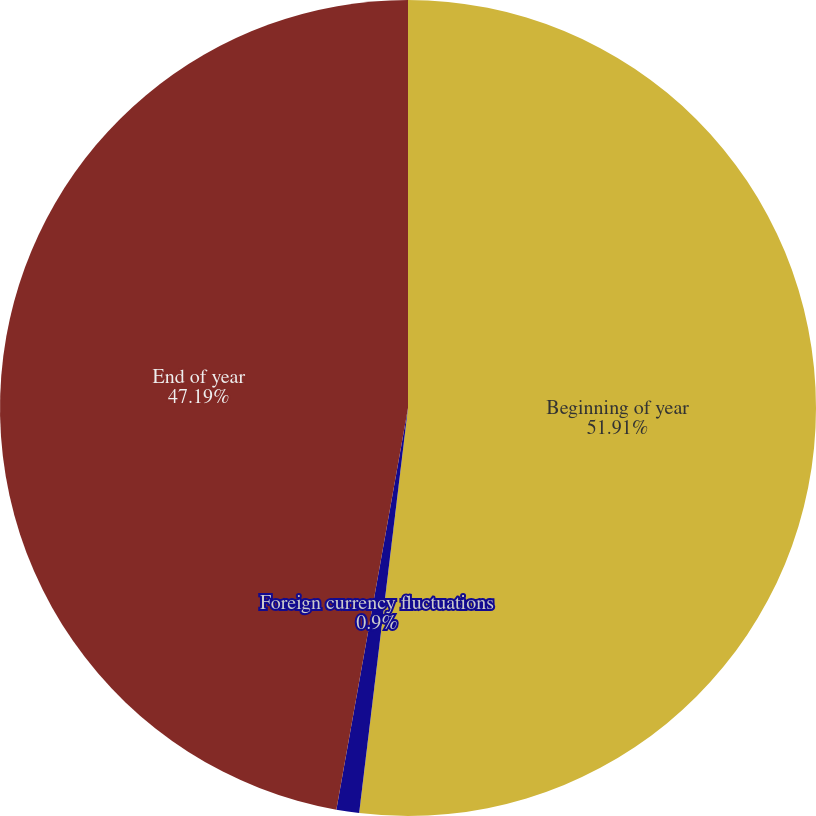Convert chart to OTSL. <chart><loc_0><loc_0><loc_500><loc_500><pie_chart><fcel>Beginning of year<fcel>Foreign currency fluctuations<fcel>End of year<nl><fcel>51.91%<fcel>0.9%<fcel>47.19%<nl></chart> 